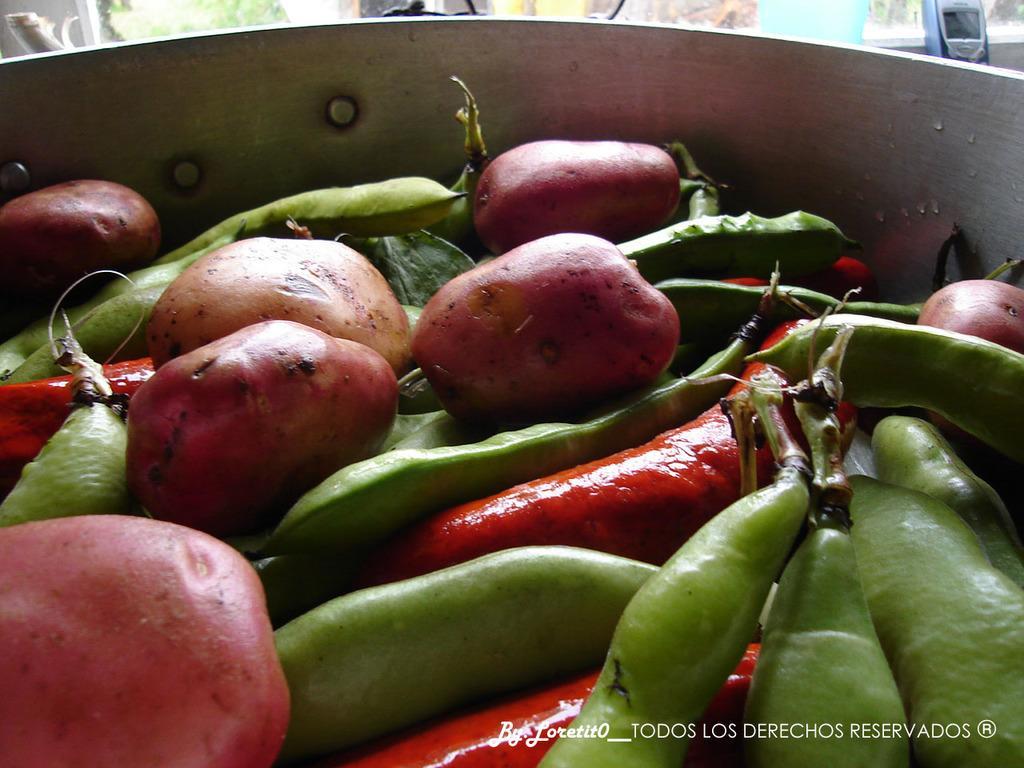Can you describe this image briefly? In this image I see a bowl in which there are potatoes, beans and red chillies and I see a mobile phone over here. 